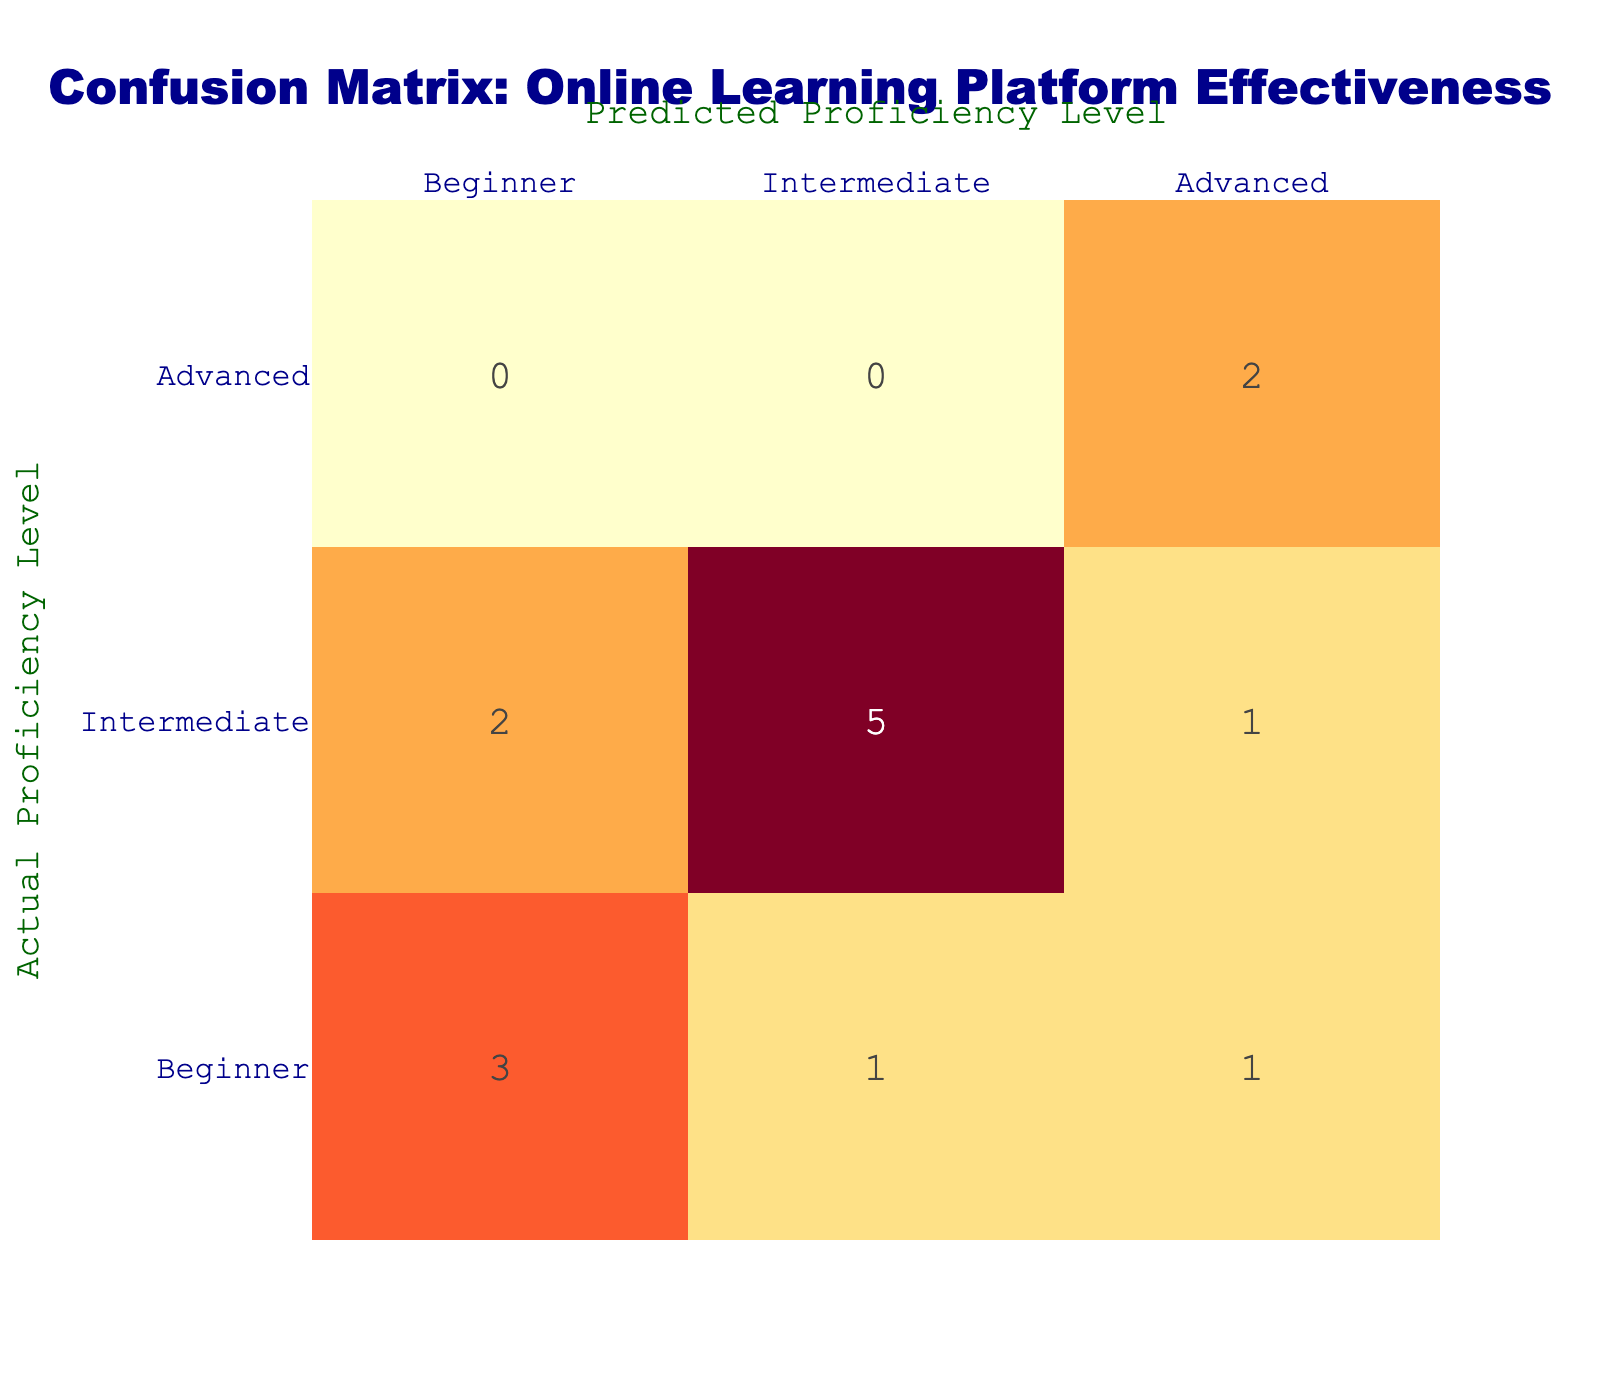What is the number of times Duolingo predicted a Beginner proficiency level? From the confusion matrix, we can see that Duolingo predicted 'Beginner' for two actual cases of 'Beginner'. So there are 2 counts for Duolingo predicting Beginner.
Answer: 2 What is the total number of actual Intermediate proficiency predictions? Counting the entries in the 'Intermediate' row of the matrix, we find three occurrences: two from Duolingo, one from Busuu, and three from Coursera, leading to a total of 6 predictions categorized as Intermediate.
Answer: 6 Did Rosetta Stone ever incorrectly predict a Beginner proficiency level? Looking at the confusion matrix, Rosetta Stone has a count of 1 where it predicted 'Advanced' when the actual proficiency was 'Beginner'. Hence, it did produce an incorrect prediction for this proficiency level.
Answer: Yes Which online learning platform had the highest count of accurate Advanced proficiency predictions? Checking the 'Advanced' column, we find that Rosetta Stone accurately predicted 'Advanced' for 2 cases and Coursera for 1 case. Thus, Rosetta Stone had the highest count of accurate predictions for this proficiency level.
Answer: Rosetta Stone What is the difference in the number of predicted Intermediate levels between Duolingo and Babbel? For Duolingo, there are 2 counts where the actual proficiency is Intermediate, and for Babbel, the count is 2 as well. Thus, the difference is computed as 2 (Duolingo) - 2 (Babbel) = 0, meaning they are equal.
Answer: 0 How many total predictions did Coursera make? By adding the counts in the Coursera row, we find predictions across three categories: 1 for Beginner, 3 for Intermediate, and 1 for Advanced, totaling 5 predictions.
Answer: 5 Which platform had the most significant discrepancy between predicted and actual proficiency levels? Evaluating errors, Rosetta Stone had 1 mistake (predicted Advanced instead of Beginner), while Coursera made 2 mistakes (predicted Intermediate instead of Advanced). Therefore, Coursera had more discrepancy.
Answer: Coursera What is the total number of accurate predictions across all proficiency levels for Babbel? Babbel accurately predicted 'Beginner' twice and 'Intermediate' twice, summing up to a total of 4 accurate predictions.
Answer: 4 How many Beginner proficiencies were predicted overall? By adding all the counts in the Beginner column: 3 from Duolingo, 1 from Babbel, 1 from Busuu, and 0 from Rosetta Stone and Coursera, the total count of predicted Beginner proficiencies is 5.
Answer: 5 